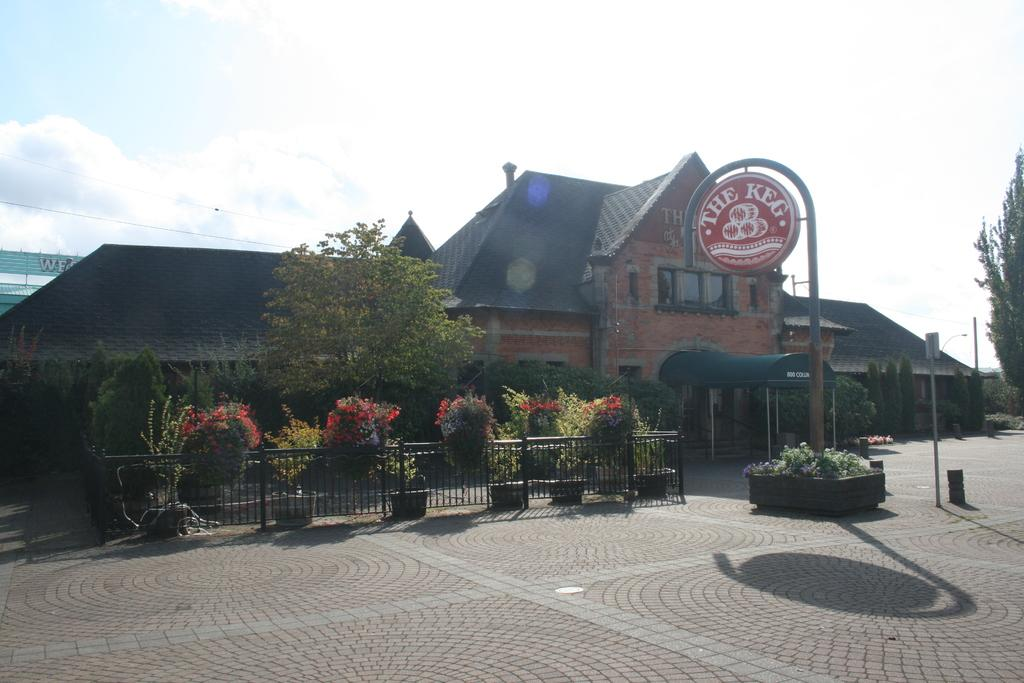What can be seen in the foreground of the image? In the foreground, there are flower plants, a pole, and a boundary. What is visible in the background of the image? In the background, there is a house, poles, a tree, and the sky. Can you describe the poster on the left side of the image? The poster is on the left side of the image, but its content is not mentioned in the facts. How many poles are visible in the image? There are poles in both the foreground and background, so at least two poles are visible. What type of slave is depicted in the image? There is no mention of a slave or any person in the image, so this question cannot be answered. What color are the clouds in the image? There is no mention of clouds in the image, so this question cannot be answered. 